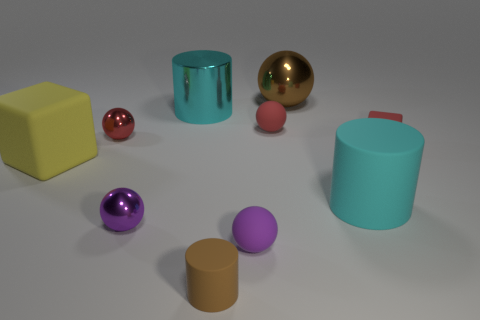There is a big cylinder behind the yellow rubber thing; is its color the same as the rubber cylinder right of the big brown sphere?
Give a very brief answer. Yes. What is the color of the large cylinder that is in front of the tiny matte block?
Give a very brief answer. Cyan. Does the block that is on the right side of the yellow rubber cube have the same size as the big metallic cylinder?
Provide a short and direct response. No. Are there fewer small things than things?
Give a very brief answer. Yes. What is the shape of the shiny thing that is the same color as the tiny rubber cube?
Provide a succinct answer. Sphere. What number of cyan cylinders are right of the tiny brown object?
Give a very brief answer. 1. Do the brown matte object and the big cyan shiny object have the same shape?
Make the answer very short. Yes. What number of small objects are both in front of the red shiny object and right of the brown rubber thing?
Keep it short and to the point. 2. What number of things are cyan metal cylinders or objects that are behind the large cyan metallic thing?
Keep it short and to the point. 2. Are there more large yellow cylinders than small purple rubber objects?
Provide a short and direct response. No. 